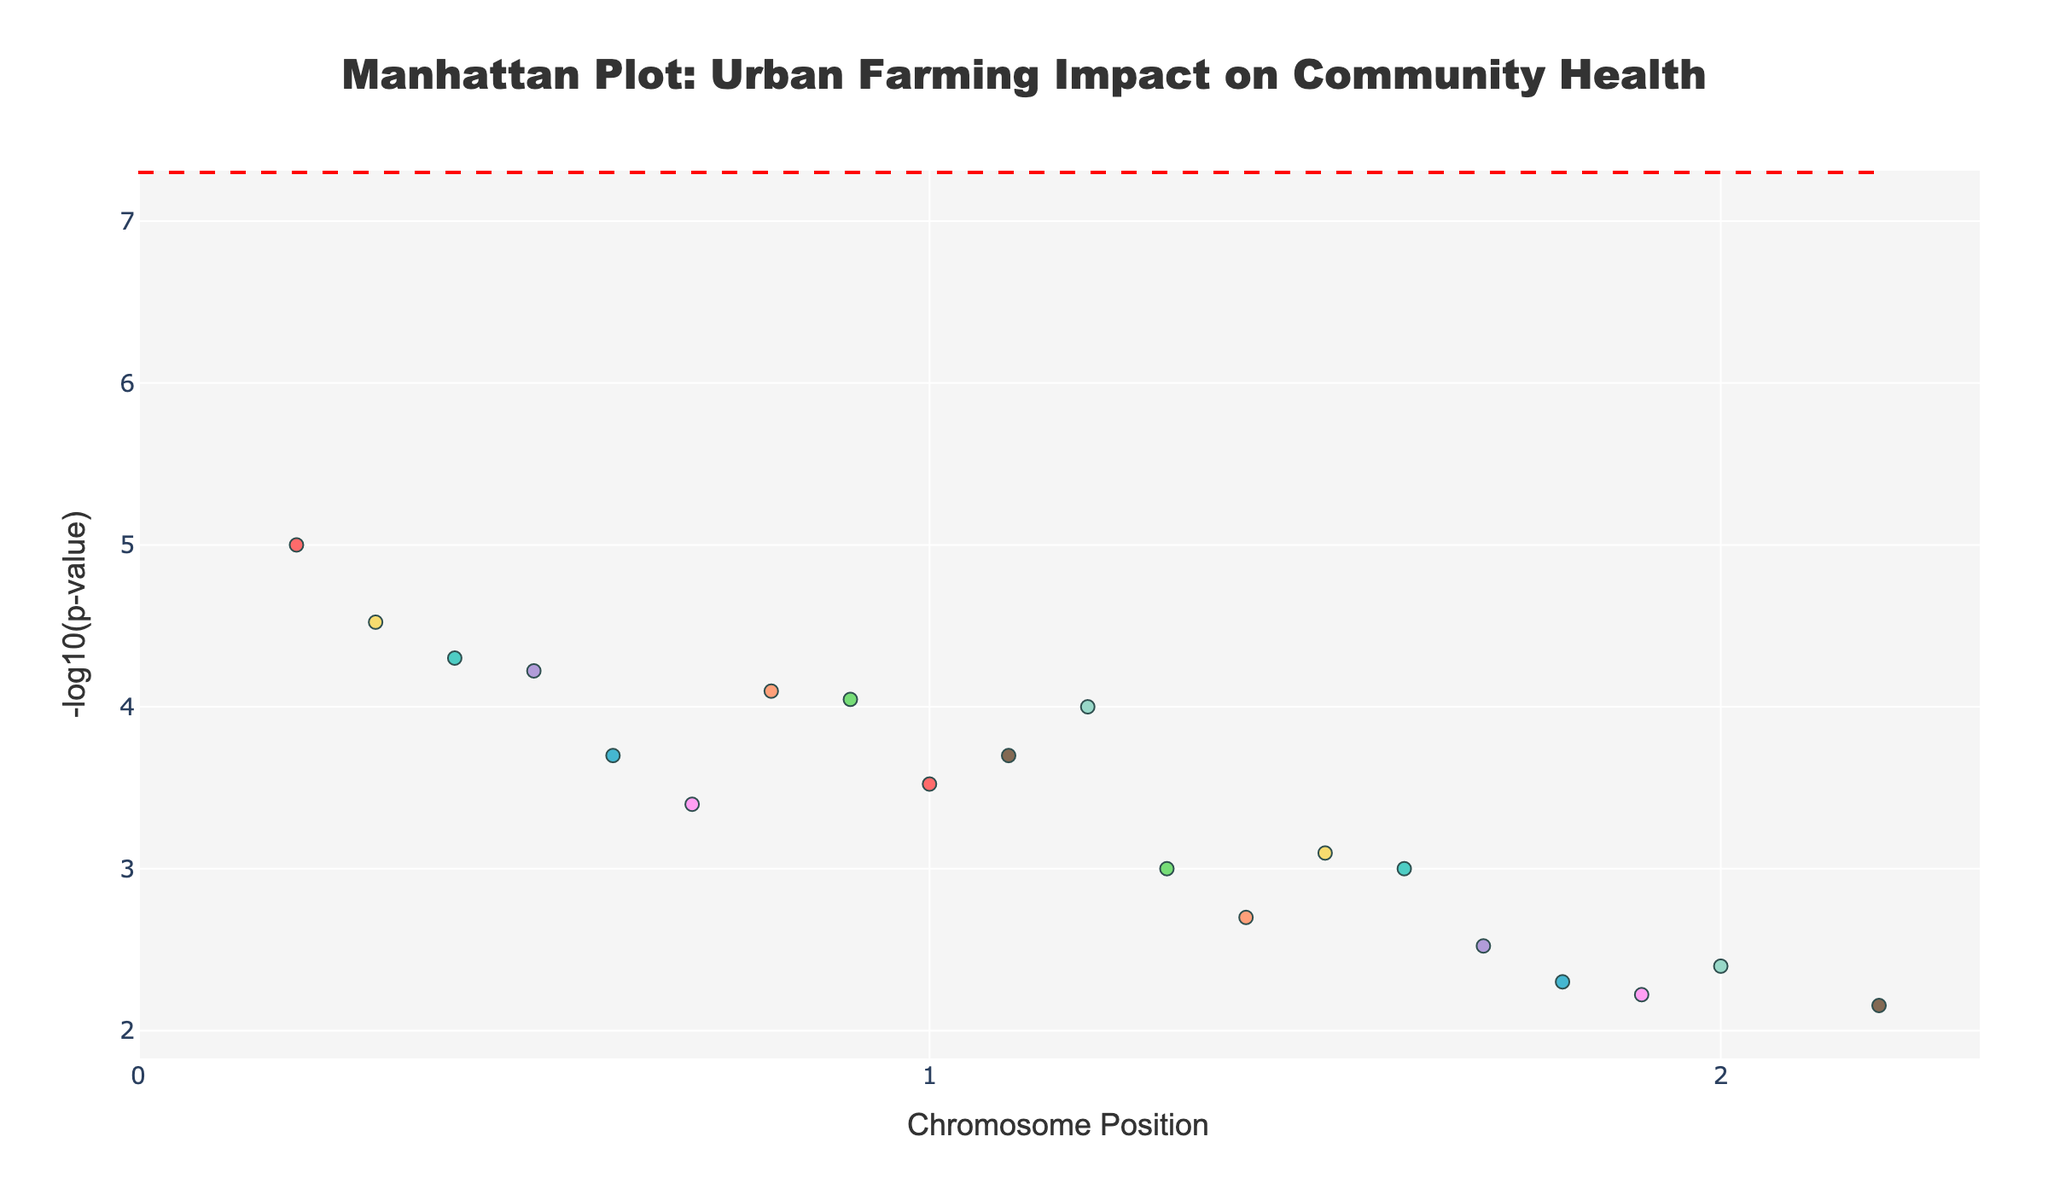what is the title of the figure? The title is typically displayed at the top of the figure. In this case, the title is 'Manhattan Plot: Urban Farming Impact on Community Health'.
Answer: 'Manhattan Plot: Urban Farming Impact on Community Health' What do the colors in the plot represent? The colors differentiate between the different chromosomes. Each chromosome has data points in a unique color to easily distinguish between them.
Answer: Different chromosomes What is the y-axis representing in the plot? The y-axis represents '-log10(p-value)'. This metric is used to show the significance of the association between urban farming participation and community health indicators.
Answer: -log10(p-value) Which community health indicator has the lowest p-value? The community health indicator with the lowest p-value will have the highest -log10(p-value) value on the y-axis. 'Physical_activity' on chromosome 1 at position 1000000 has the highest y-value.
Answer: Physical_activity How many community health indicators have a p-value less than 0.0001? To find this, we identify the points above the -log10(0.0001) threshold, which is 4. These points are 'Physical_activity', 'Fruit_vegetable_consumption', 'Air_quality_perception', and 'Green_space_access'.
Answer: 4 Which chromosome has the highest number of community health indicators with significant associations? By visually scanning for the chromosome with the most data points above the significance line, chromosome 1 has multiple indicators above this line.
Answer: Chromosome 1 Are there any indicators with a p-value greater than 0.001? Points below -log10(0.001) on the y-axis have a p-value greater than 0.001. Indicators like 'Mental_health_score', 'Stress_levels', 'Neighborhood_satisfaction', 'Community_engagement', 'Respiratory_health', 'Life_satisfaction', 'Blood_pressure', and 'Cardiovascular_health' fit this criteria.
Answer: Yes Which community health indicators appear on chromosome 10? Look at chromosome 10's color-coded data points and read the hover information for their names. They are 'Environmental_awareness' and 'Cardiovascular_health'.
Answer: 'Environmental_awareness', 'Cardiovascular_health' What is the relationship between 'Dietary_diversity' and 'Life_satisfaction' on chromosome 7 in terms of their p-values? Look at the -log10(p-value) for 'Dietary_diversity' and 'Life_satisfaction'. 'Dietary_diversity' has a higher y-value compared to 'Life_satisfaction', indicating a lower p-value.
Answer: 'Dietary_diversity' has a lower p-value How is a trend identified in the Manhattan plot? Trends can be identified by looking at clusters of data points that show consistent values and patterns across different chromosomes. For example, more points clustered above the significance threshold line across multiple chromosomes would indicate a stronger association trend.
Answer: Clusters of significant points 